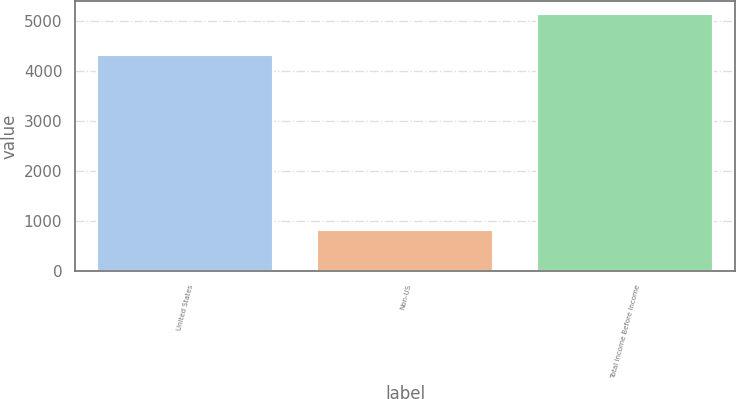Convert chart to OTSL. <chart><loc_0><loc_0><loc_500><loc_500><bar_chart><fcel>United States<fcel>Non-US<fcel>Total Income Before Income<nl><fcel>4322<fcel>814<fcel>5136<nl></chart> 